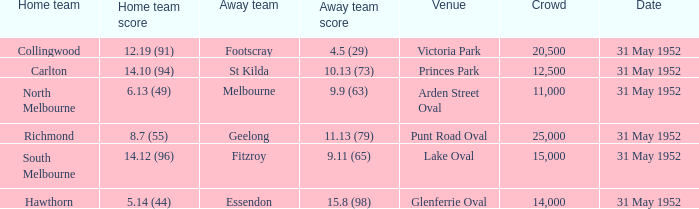When was the game when Footscray was the away team? 31 May 1952. 